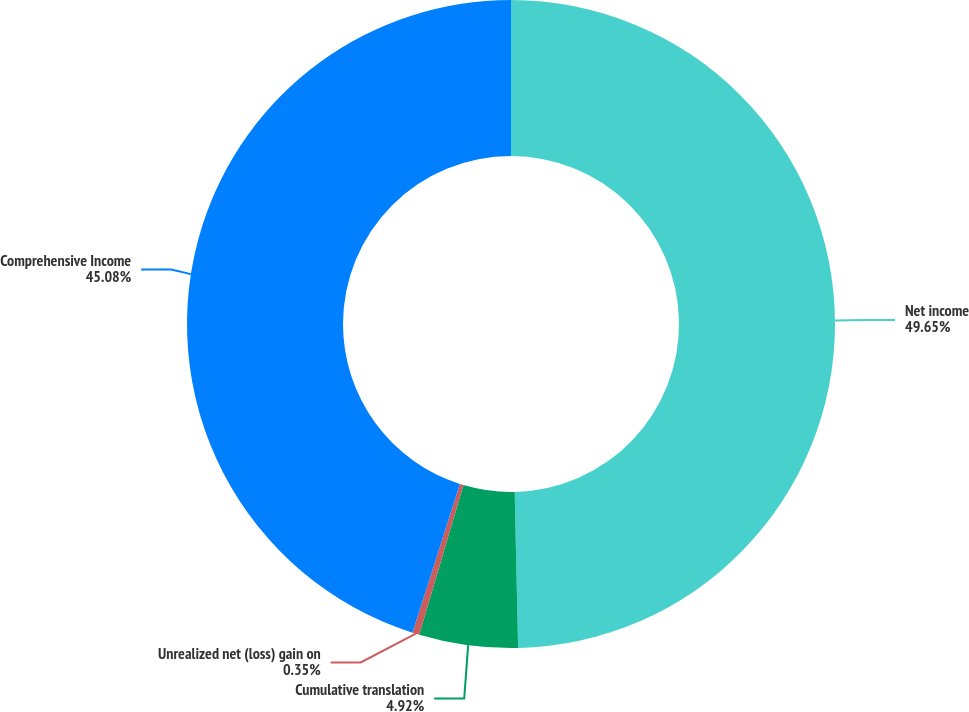Convert chart. <chart><loc_0><loc_0><loc_500><loc_500><pie_chart><fcel>Net income<fcel>Cumulative translation<fcel>Unrealized net (loss) gain on<fcel>Comprehensive Income<nl><fcel>49.65%<fcel>4.92%<fcel>0.35%<fcel>45.08%<nl></chart> 